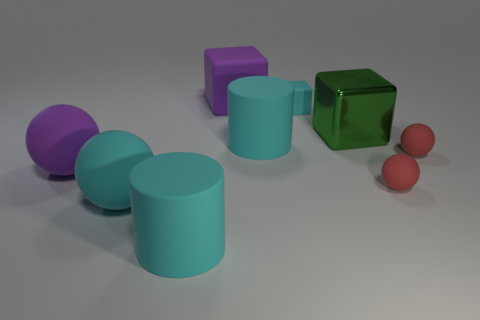Add 1 large metallic cubes. How many objects exist? 10 Subtract all big green blocks. How many blocks are left? 2 Subtract all blocks. How many objects are left? 6 Add 2 small red rubber things. How many small red rubber things are left? 4 Add 5 large blocks. How many large blocks exist? 7 Subtract all cyan balls. How many balls are left? 3 Subtract 0 brown blocks. How many objects are left? 9 Subtract 2 cylinders. How many cylinders are left? 0 Subtract all yellow spheres. Subtract all gray cylinders. How many spheres are left? 4 Subtract all blue cubes. How many cyan spheres are left? 1 